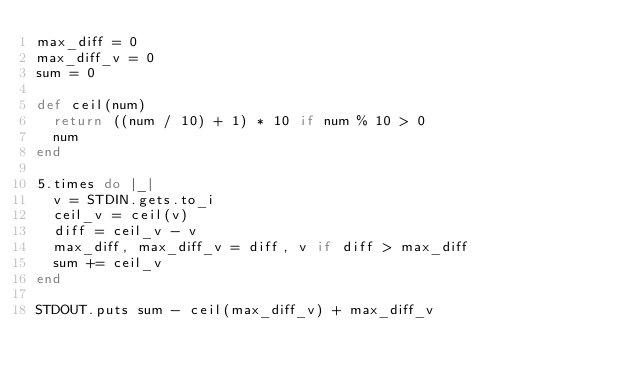Convert code to text. <code><loc_0><loc_0><loc_500><loc_500><_Ruby_>max_diff = 0
max_diff_v = 0
sum = 0

def ceil(num)
  return ((num / 10) + 1) * 10 if num % 10 > 0
  num
end

5.times do |_|
  v = STDIN.gets.to_i
  ceil_v = ceil(v)
  diff = ceil_v - v
  max_diff, max_diff_v = diff, v if diff > max_diff
  sum += ceil_v
end

STDOUT.puts sum - ceil(max_diff_v) + max_diff_v</code> 